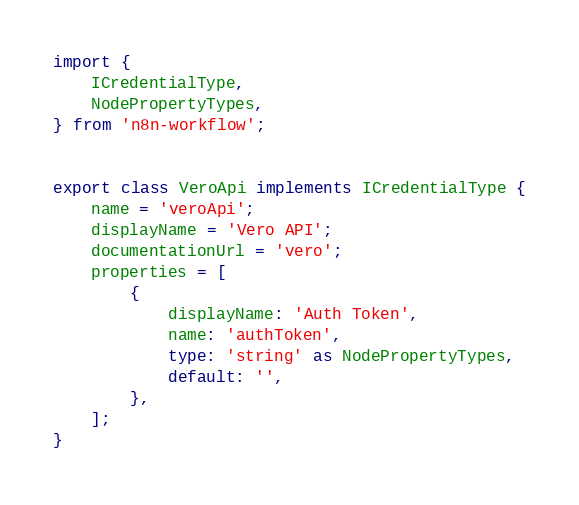Convert code to text. <code><loc_0><loc_0><loc_500><loc_500><_TypeScript_>import {
	ICredentialType,
	NodePropertyTypes,
} from 'n8n-workflow';


export class VeroApi implements ICredentialType {
	name = 'veroApi';
	displayName = 'Vero API';
	documentationUrl = 'vero';
	properties = [
		{
			displayName: 'Auth Token',
			name: 'authToken',
			type: 'string' as NodePropertyTypes,
			default: '',
		},
	];
}
</code> 